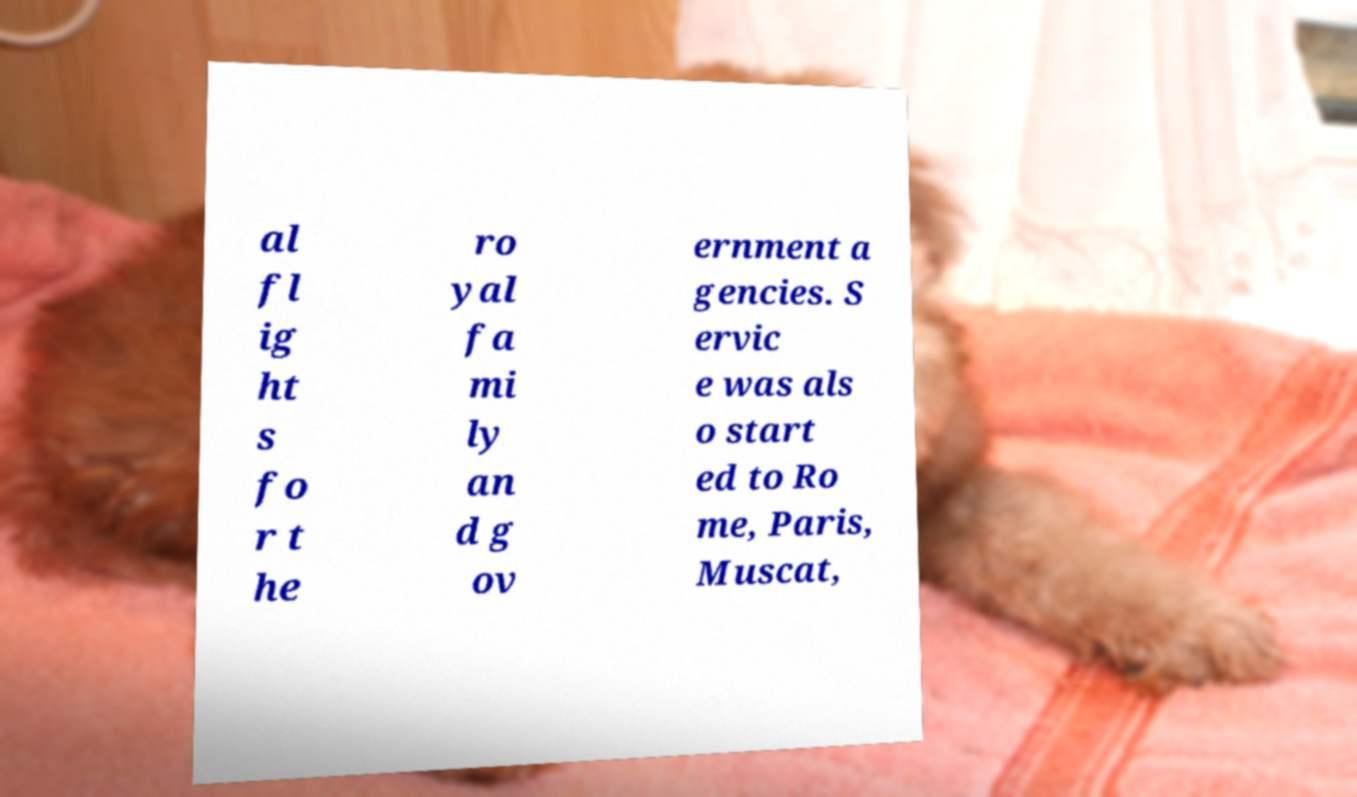Can you read and provide the text displayed in the image?This photo seems to have some interesting text. Can you extract and type it out for me? al fl ig ht s fo r t he ro yal fa mi ly an d g ov ernment a gencies. S ervic e was als o start ed to Ro me, Paris, Muscat, 